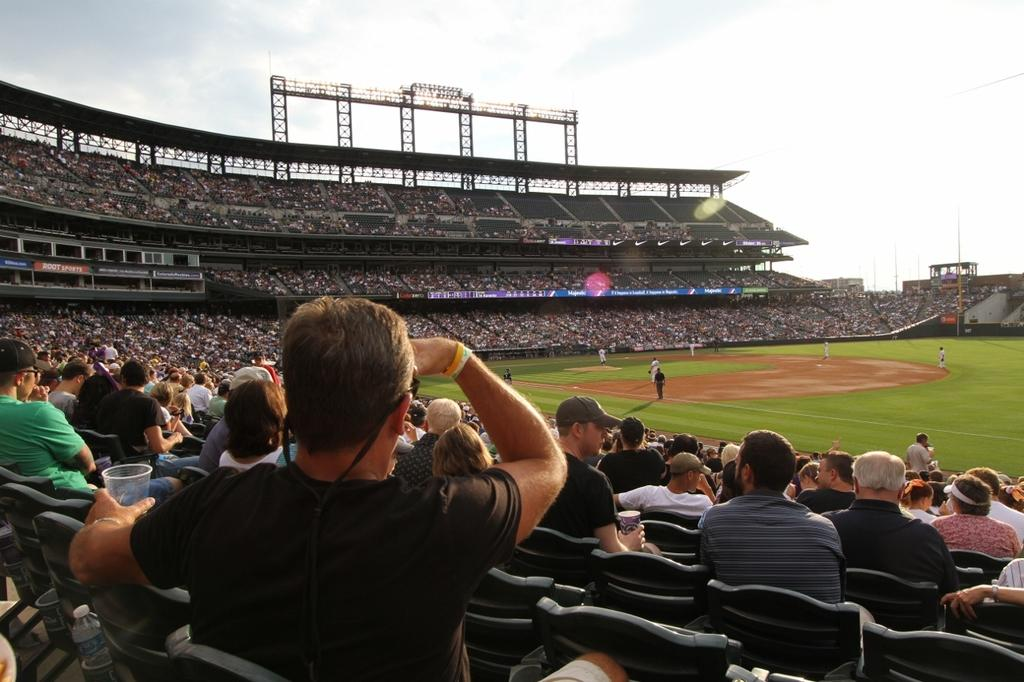How many groups of people can be seen in the image? There are two groups of people in the image. Where are the people in the first group located? The people in the first group are in an open area, likely a ground. What are the people in the second group doing? The people in the second group are sitting in a stadium surrounding the ground and watching the people in the ground. What type of zipper can be seen on the clothing of the people in the image? There is no mention of zippers or clothing in the provided facts, so it cannot be determined from the image. 